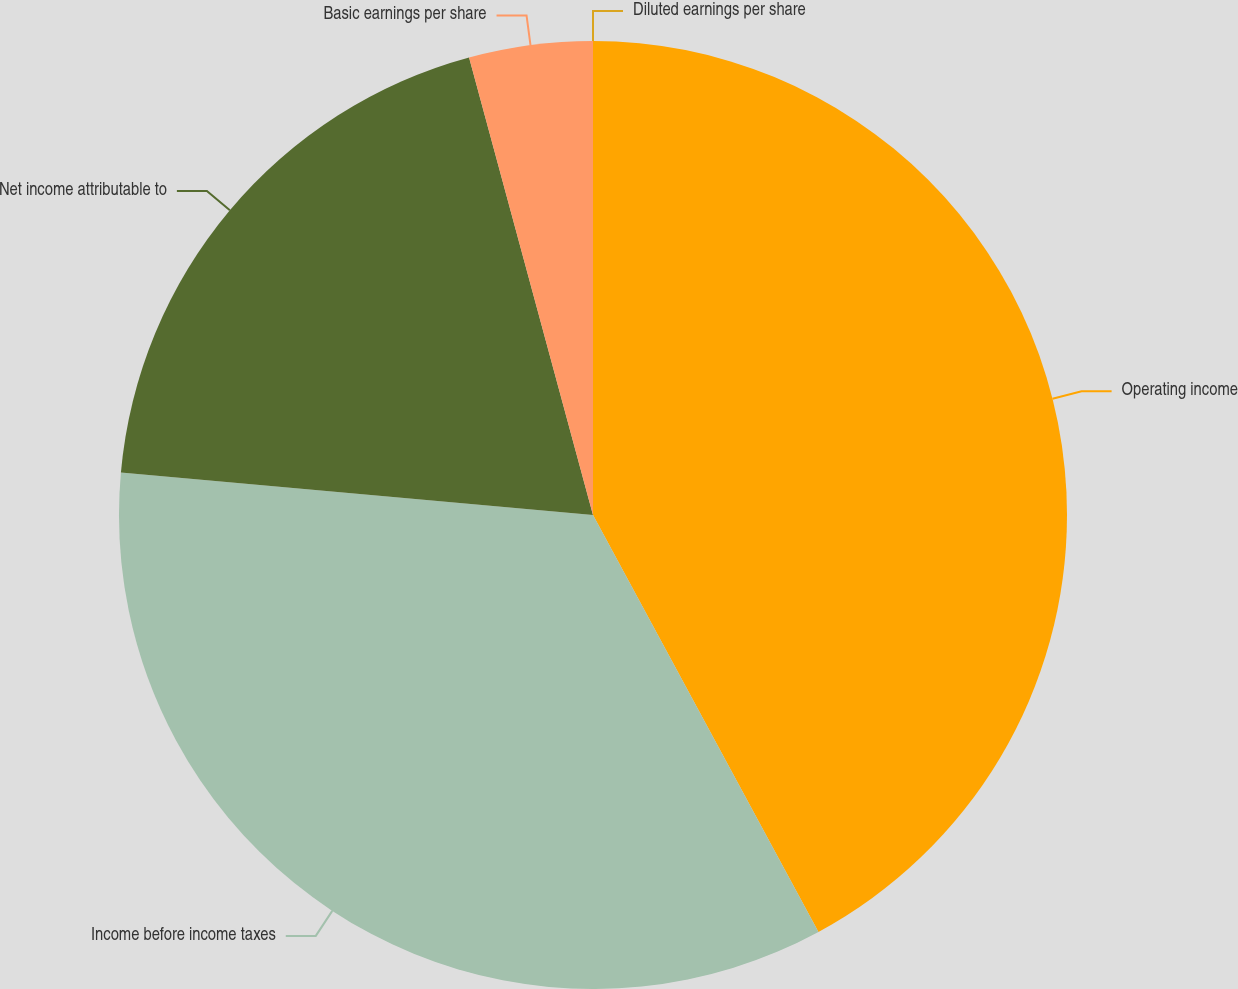Convert chart. <chart><loc_0><loc_0><loc_500><loc_500><pie_chart><fcel>Operating income<fcel>Income before income taxes<fcel>Net income attributable to<fcel>Basic earnings per share<fcel>Diluted earnings per share<nl><fcel>42.11%<fcel>34.32%<fcel>19.36%<fcel>4.21%<fcel>0.0%<nl></chart> 